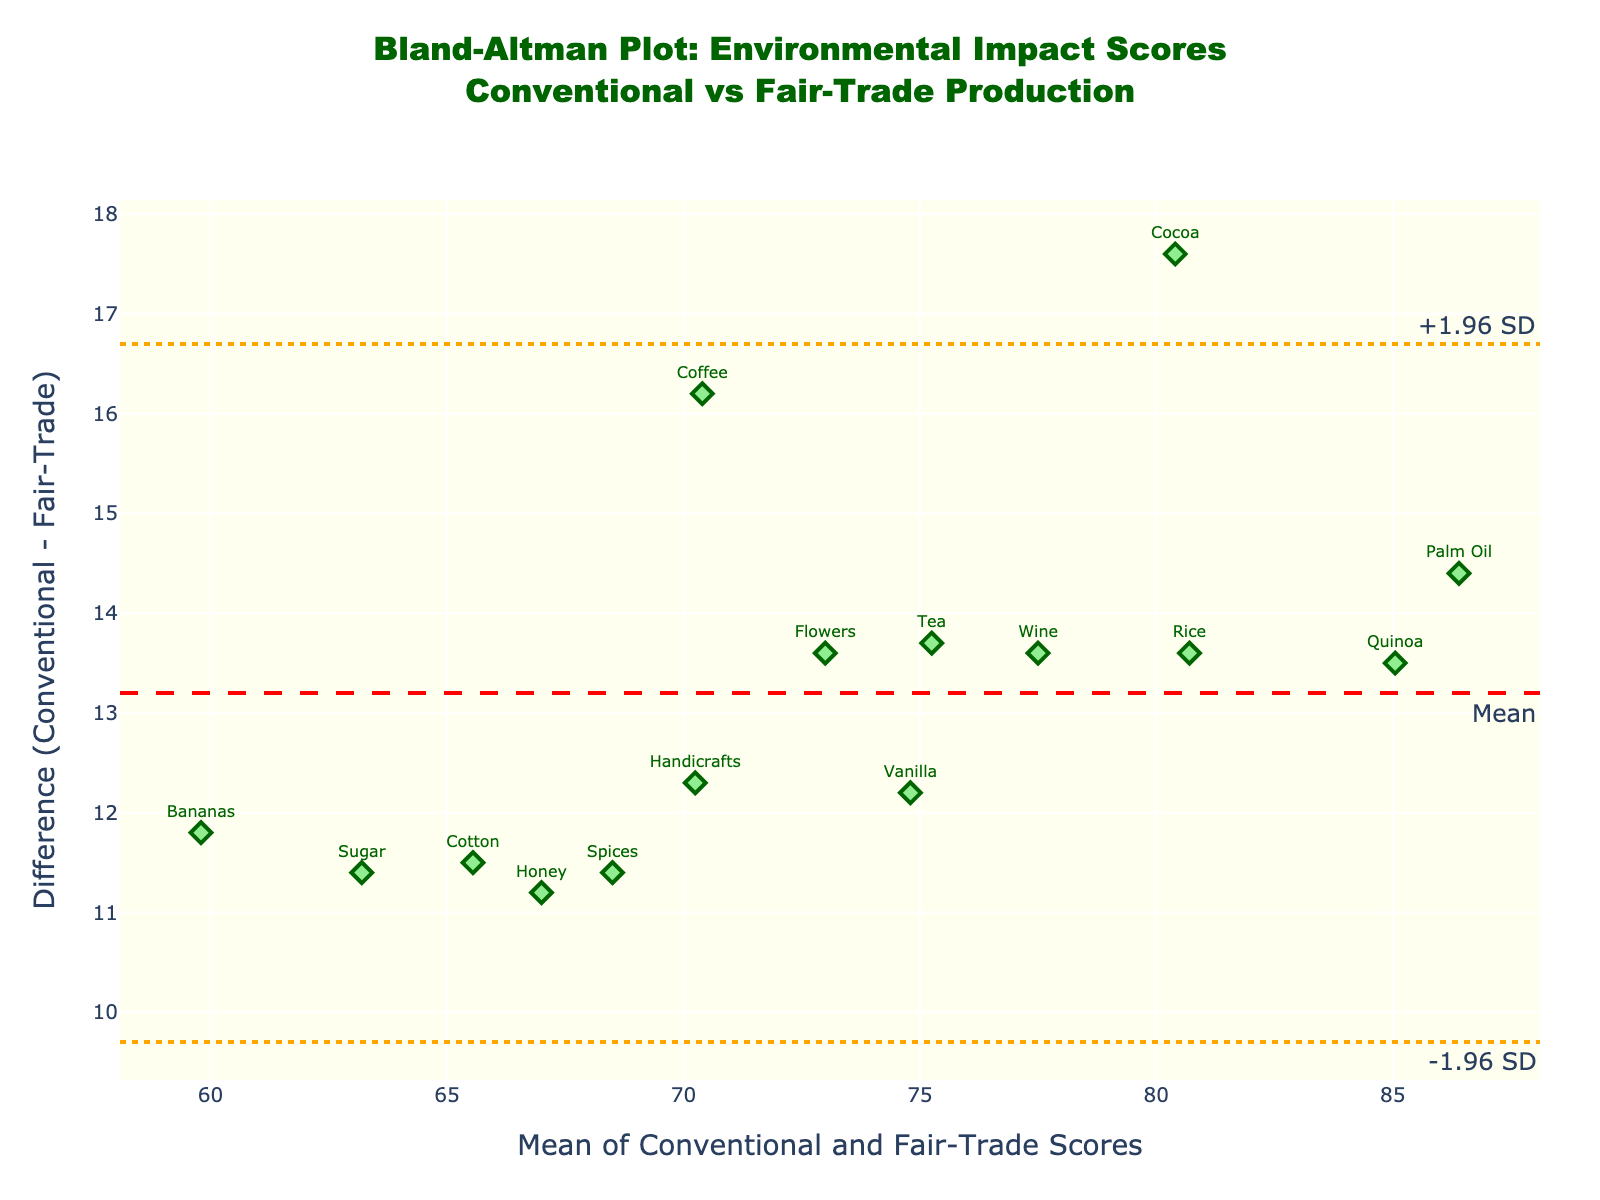What is the title of the plot? The title is at the top. It reads "Bland-Altman Plot: Environmental Impact Scores<br>Conventional vs Fair-Trade Production."
Answer: Bland-Altman Plot: Environmental Impact Scores Conventional vs Fair-Trade Production What color are the markers representing the data points? The markers are colored light green with a darker green outline.
Answer: Light green How many industries are represented in the plot? Each marker represents an industry and there is text for each one. Count these texts. There are 15 industries listed in the dataset.
Answer: 15 Which industry has the highest mean environmental impact score? Find the point with the highest x-value, representing the mean score. The text for this point is "Palm Oil."
Answer: Palm Oil What is the line color representing the mean difference? The mean difference line is annotated "Mean" and is colored red.
Answer: Red What are the values of the upper and lower limits of agreement? The upper and lower limit lines are annotated "+1.96 SD" and "-1.96 SD," respectively. Their y-values are the limits.
Answer: Approximately 17.14 and 11.89 How does the environmental impact score of conventional production for cocoa compare to fair-trade production? Look for "Cocoa" and compare its difference (the y-coordinate). The difference is positive, indicating the conventional score is higher.
Answer: Higher What is the mean difference in environmental impact scores between conventional and fair-trade production methods? The mean difference is annotated on the red line, and it's approximately 13.52.
Answer: 13.52 Which industry shows the smallest difference in environmental impact scores between conventional and fair-trade methods? Look for the point closest to y = 0. "Handicrafts" has the smallest difference.
Answer: Handicrafts Is there any industry whose data point falls outside the limits of agreement? Check if any point lies beyond the dashed lines for ±1.96 SD. All points fall within these lines.
Answer: No 